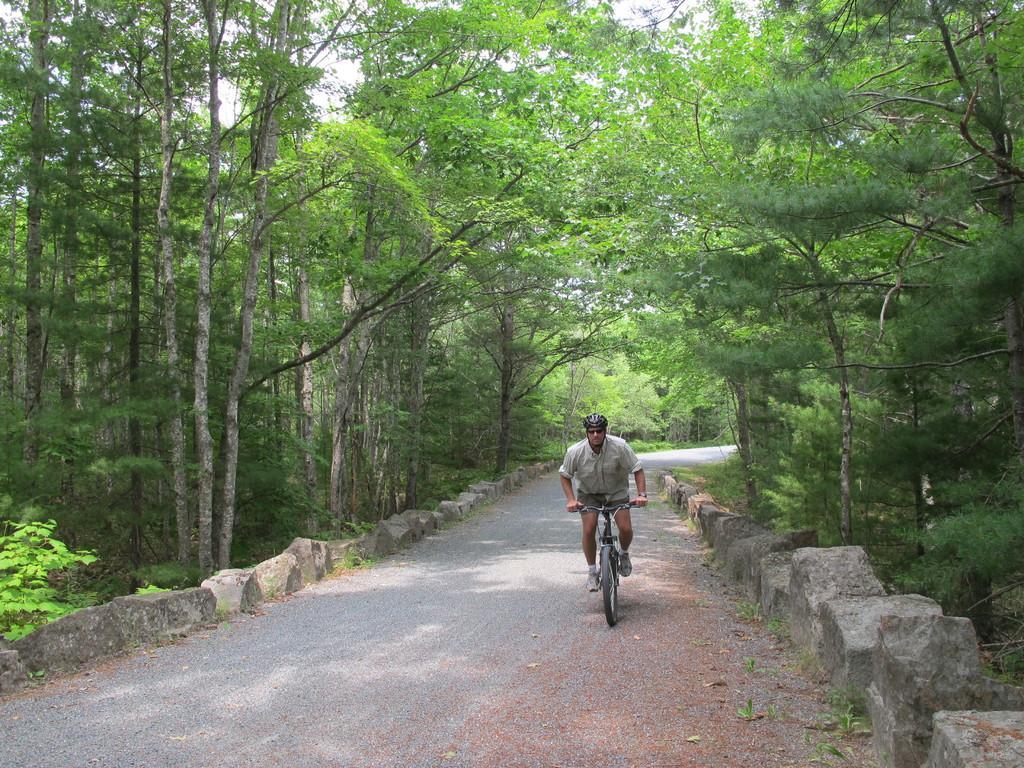Can you describe this image briefly? In this image I can see a person sitting on the bicycle. I can see the road. On the left and right side, I can see the trees. 